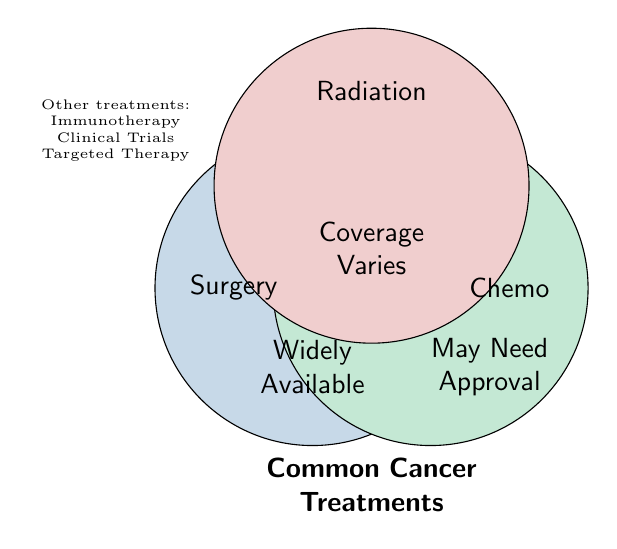Which treatment type is widely available? The Venn Diagram shows that Surgery falls in the circle labeled "Widely Available."
Answer: Surgery Which treatment types fall under "Coverage Varies"? By looking at the overlapping areas in the Venn Diagram, Radiation Therapy is placed within "Coverage Varies."
Answer: Radiation Therapy How many common cancer treatments are represented in the diagram? The title indicates "Common Cancer Treatments," and the Venn Diagram lists Surgery, Chemotherapy, and Radiation Therapy, totaling 3 treatments.
Answer: 3 Which treatments may need approval to access? The diagram shows Chemo within the circle labeled "May Need Approval."
Answer: Chemotherapy What treatments are listed outside the main circles? The smaller text outside the primary circles includes Immunotherapy, Clinical Trials, and Targeted Therapy, denoting other treatments.
Answer: Immunotherapy, Clinical Trials, Targeted Therapy Compare the availability of Surgery and Chemotherapy. Which one has broader access? Surgery is listed as "Widely Available," while Chemotherapy falls under "May Need Approval." Thus, Surgery has broader access.
Answer: Surgery Does Radiation Therapy generally have standard insurance coverage? Radiation Therapy falls under "Coverage Varies," indicating that its insurance coverage is not standard and varies by plan.
Answer: No What category does Immunotherapy fall under in terms of availability? Immunotherapy is listed outside the main circles under "Other treatments," indicating limited availability.
Answer: Limited Availability 